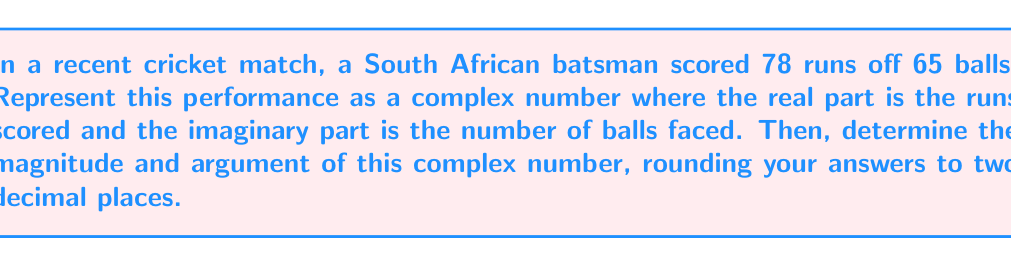Provide a solution to this math problem. Let's approach this step-by-step:

1) First, we represent the batting performance as a complex number:
   $z = 78 + 65i$

2) To find the magnitude of a complex number $z = a + bi$, we use the formula:
   $|z| = \sqrt{a^2 + b^2}$

3) Substituting our values:
   $|z| = \sqrt{78^2 + 65^2}$
   $|z| = \sqrt{6084 + 4225}$
   $|z| = \sqrt{10309}$
   $|z| \approx 101.53$

4) To find the argument of a complex number, we use the formula:
   $\arg(z) = \tan^{-1}(\frac{b}{a})$

5) Substituting our values:
   $\arg(z) = \tan^{-1}(\frac{65}{78})$
   $\arg(z) \approx 0.6947$ radians

6) To convert radians to degrees, we multiply by $\frac{180}{\pi}$:
   $0.6947 \times \frac{180}{\pi} \approx 39.79°$

Therefore, the magnitude is approximately 101.53, and the argument is approximately 39.79°.
Answer: Magnitude: 101.53, Argument: 39.79° 